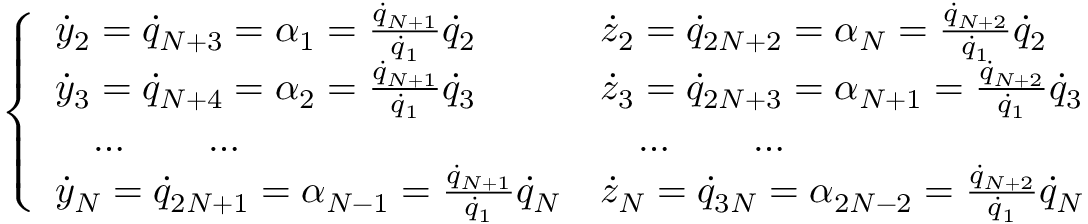Convert formula to latex. <formula><loc_0><loc_0><loc_500><loc_500>\left \{ \begin{array} { l l } { { \dot { y } } _ { 2 } = { \dot { q } } _ { N + 3 } = \alpha _ { 1 } = \frac { { \dot { q } } _ { N + 1 } } { { \dot { q } _ { 1 } } } { \dot { q } } _ { 2 } } & { { \dot { z } } _ { 2 } = { \dot { q } } _ { 2 N + 2 } = \alpha _ { N } = \frac { { \dot { q } } _ { N + 2 } } { { \dot { q } _ { 1 } } } { \dot { q } } _ { 2 } } \\ { { \dot { y } } _ { 3 } = { \dot { q } } _ { N + 4 } = \alpha _ { 2 } = \frac { { \dot { q } } _ { N + 1 } } { { \dot { q } _ { 1 } } } { \dot { q } } _ { 3 } } & { { \dot { z } } _ { 3 } = { \dot { q } } _ { 2 N + 3 } = \alpha _ { N + 1 } = \frac { { \dot { q } } _ { N + 2 } } { { \dot { q } _ { 1 } } } { \dot { q } } _ { 3 } } \\ { \quad \dots \quad \dots } & { \quad \dots \quad \dots } \\ { { \dot { y } } _ { N } = { \dot { q } } _ { 2 N + 1 } = \alpha _ { N - 1 } = \frac { { \dot { q } } _ { N + 1 } } { { \dot { q } _ { 1 } } } { \dot { q } } _ { N } } & { { \dot { z } } _ { N } = { \dot { q } } _ { 3 N } = \alpha _ { 2 N - 2 } = \frac { { \dot { q } } _ { N + 2 } } { { \dot { q } _ { 1 } } } { \dot { q } } _ { N } } \end{array}</formula> 